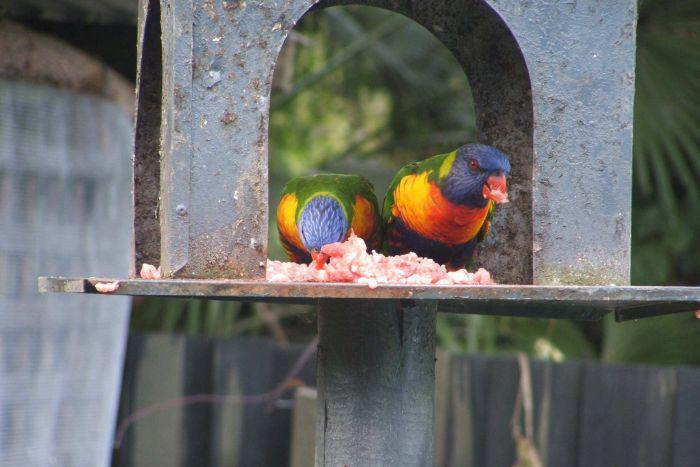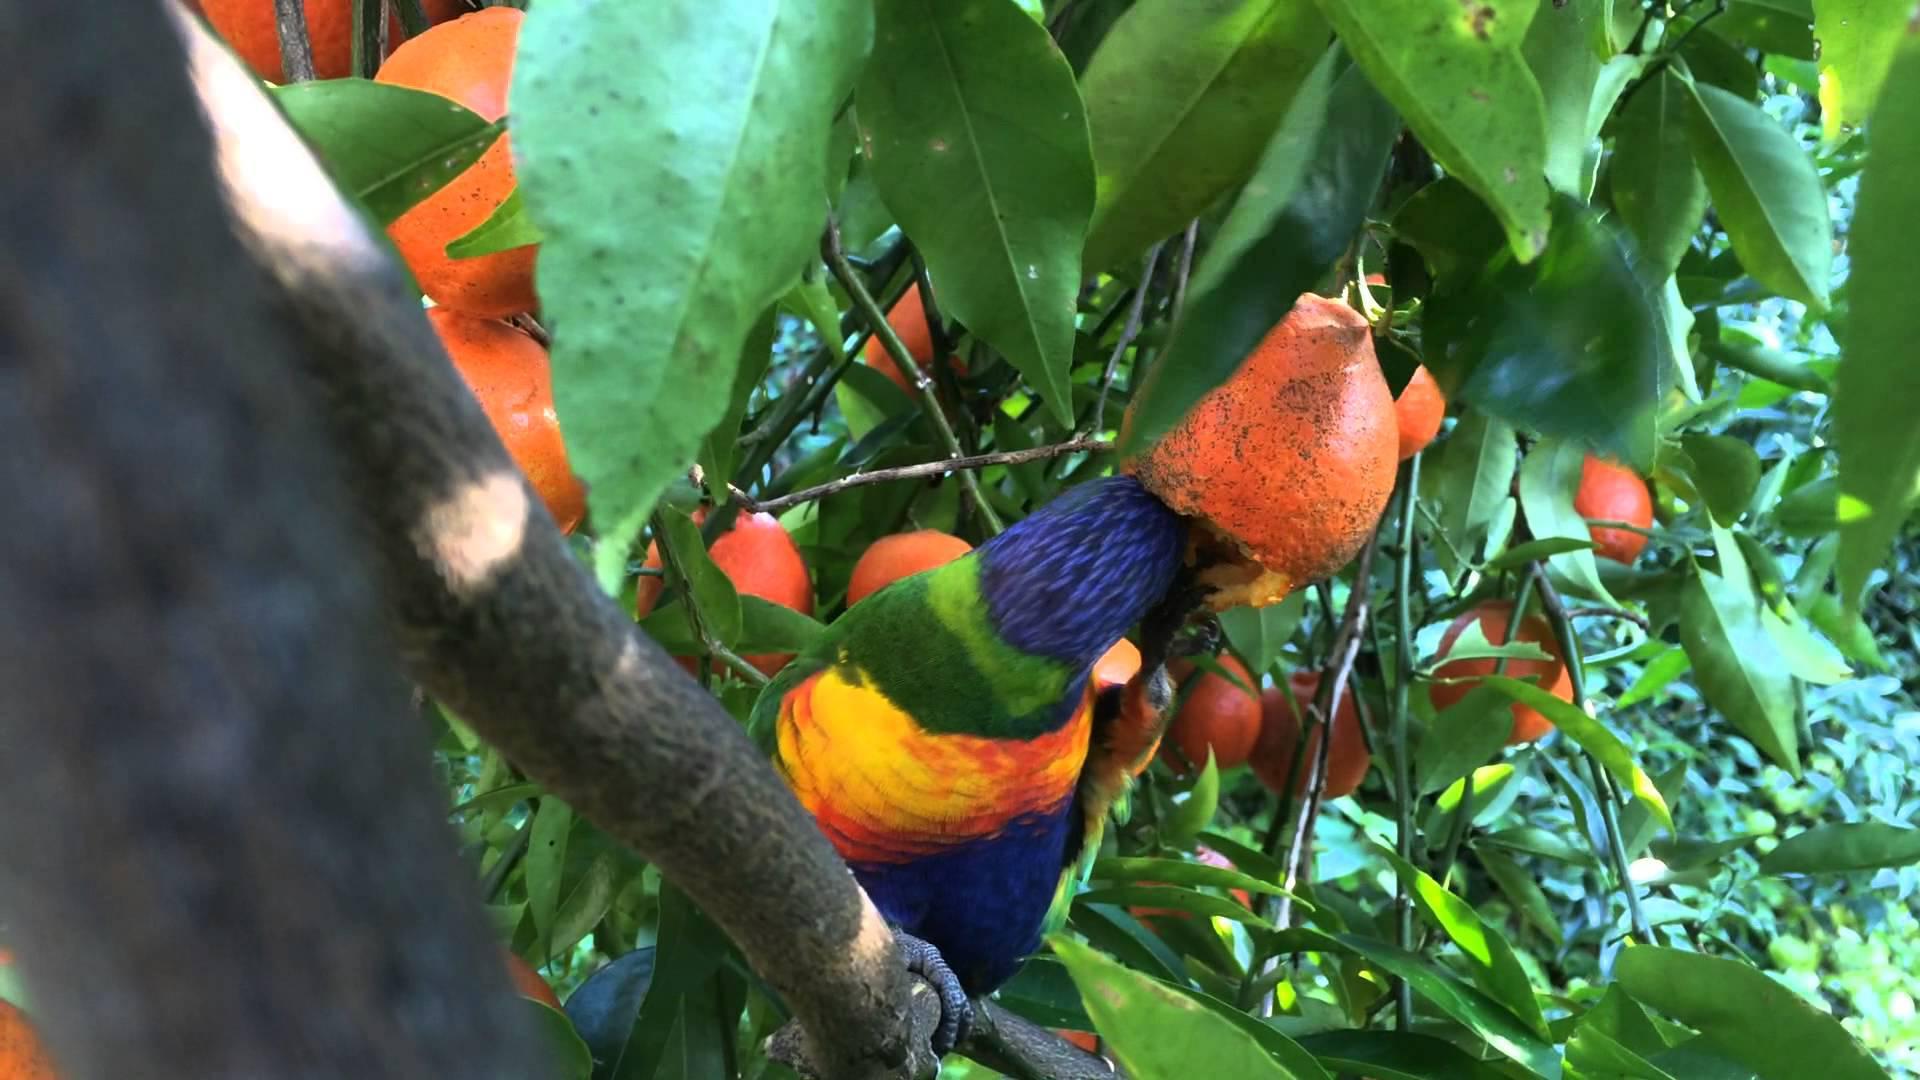The first image is the image on the left, the second image is the image on the right. For the images displayed, is the sentence "There are at least four birds in total." factually correct? Answer yes or no. No. 